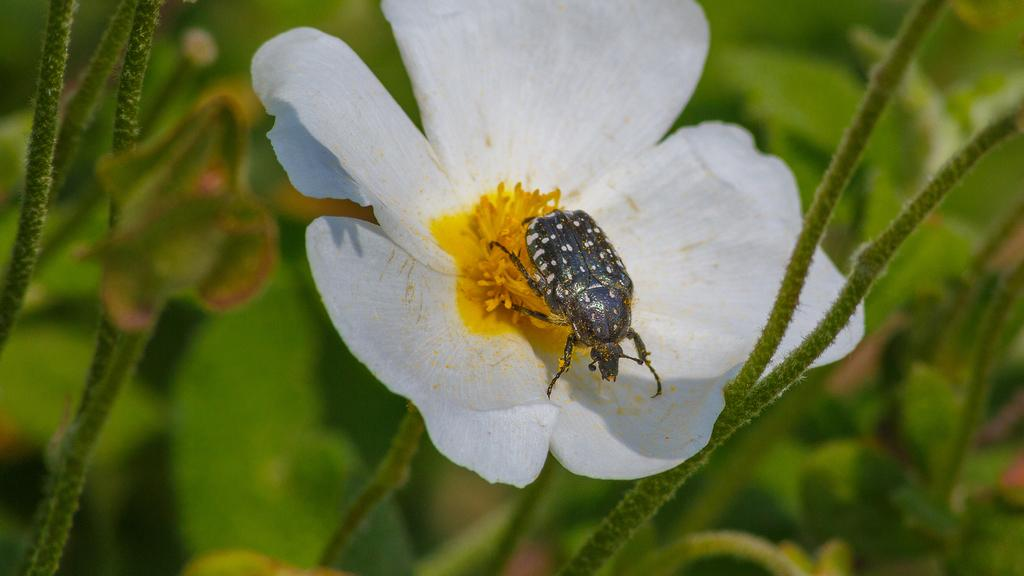What type of creature is in the image? There is an insect in the image. What color is the insect? The insect is black in color. Where is the insect located in the image? The insect is on a flower. What colors are present on the flower? The flower is white and yellow in color. What color is the background of the image? The background of the image is green. What type of beef is being offered in the image? There is no beef present in the image; it features an insect on a flower with a green background. 